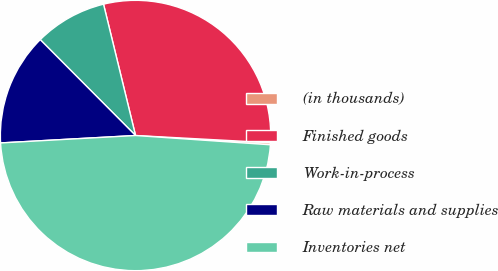<chart> <loc_0><loc_0><loc_500><loc_500><pie_chart><fcel>(in thousands)<fcel>Finished goods<fcel>Work-in-process<fcel>Raw materials and supplies<fcel>Inventories net<nl><fcel>0.24%<fcel>29.66%<fcel>8.65%<fcel>13.42%<fcel>48.03%<nl></chart> 